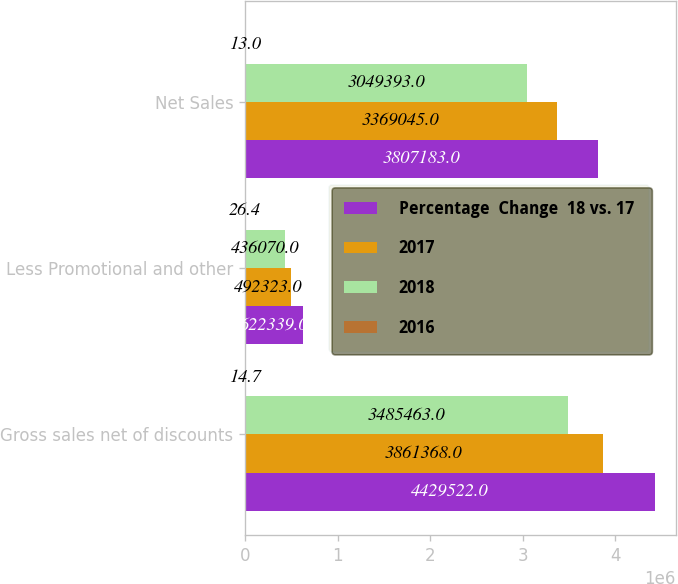Convert chart to OTSL. <chart><loc_0><loc_0><loc_500><loc_500><stacked_bar_chart><ecel><fcel>Gross sales net of discounts<fcel>Less Promotional and other<fcel>Net Sales<nl><fcel>Percentage  Change  18 vs. 17<fcel>4.42952e+06<fcel>622339<fcel>3.80718e+06<nl><fcel>2017<fcel>3.86137e+06<fcel>492323<fcel>3.36904e+06<nl><fcel>2018<fcel>3.48546e+06<fcel>436070<fcel>3.04939e+06<nl><fcel>2016<fcel>14.7<fcel>26.4<fcel>13<nl></chart> 